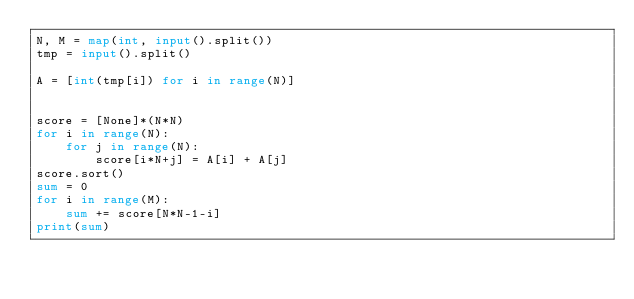Convert code to text. <code><loc_0><loc_0><loc_500><loc_500><_Python_>N, M = map(int, input().split())
tmp = input().split()

A = [int(tmp[i]) for i in range(N)]


score = [None]*(N*N)
for i in range(N):
    for j in range(N):
        score[i*N+j] = A[i] + A[j]
score.sort()
sum = 0
for i in range(M):
    sum += score[N*N-1-i]
print(sum)</code> 